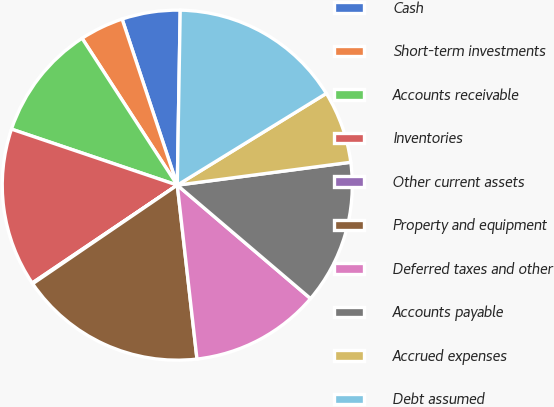<chart> <loc_0><loc_0><loc_500><loc_500><pie_chart><fcel>Cash<fcel>Short-term investments<fcel>Accounts receivable<fcel>Inventories<fcel>Other current assets<fcel>Property and equipment<fcel>Deferred taxes and other<fcel>Accounts payable<fcel>Accrued expenses<fcel>Debt assumed<nl><fcel>5.37%<fcel>4.05%<fcel>10.66%<fcel>14.63%<fcel>0.08%<fcel>17.27%<fcel>11.98%<fcel>13.31%<fcel>6.69%<fcel>15.95%<nl></chart> 